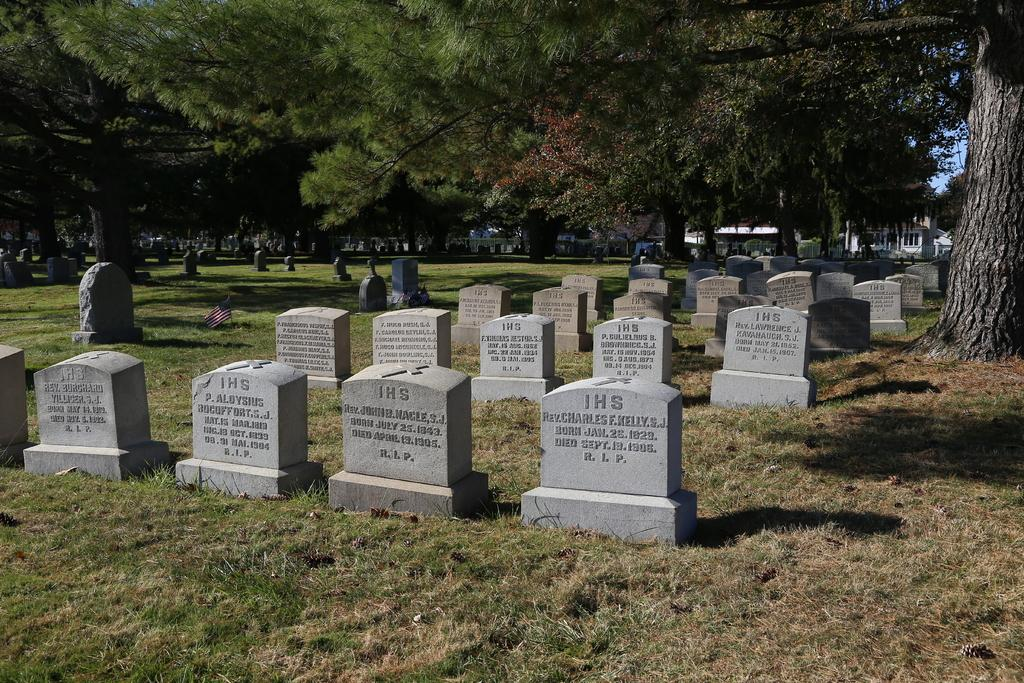What type of location is depicted in the image? The image contains a graveyard. What can be found within the graveyard? The graveyard has numerous graves. What can be seen in the distance from the graveyard? There are trees visible in the distance from the graveyard. What type of club can be seen being used by the people in the image? There are no people or clubs present in the image; it features a graveyard with graves and trees in the distance. 